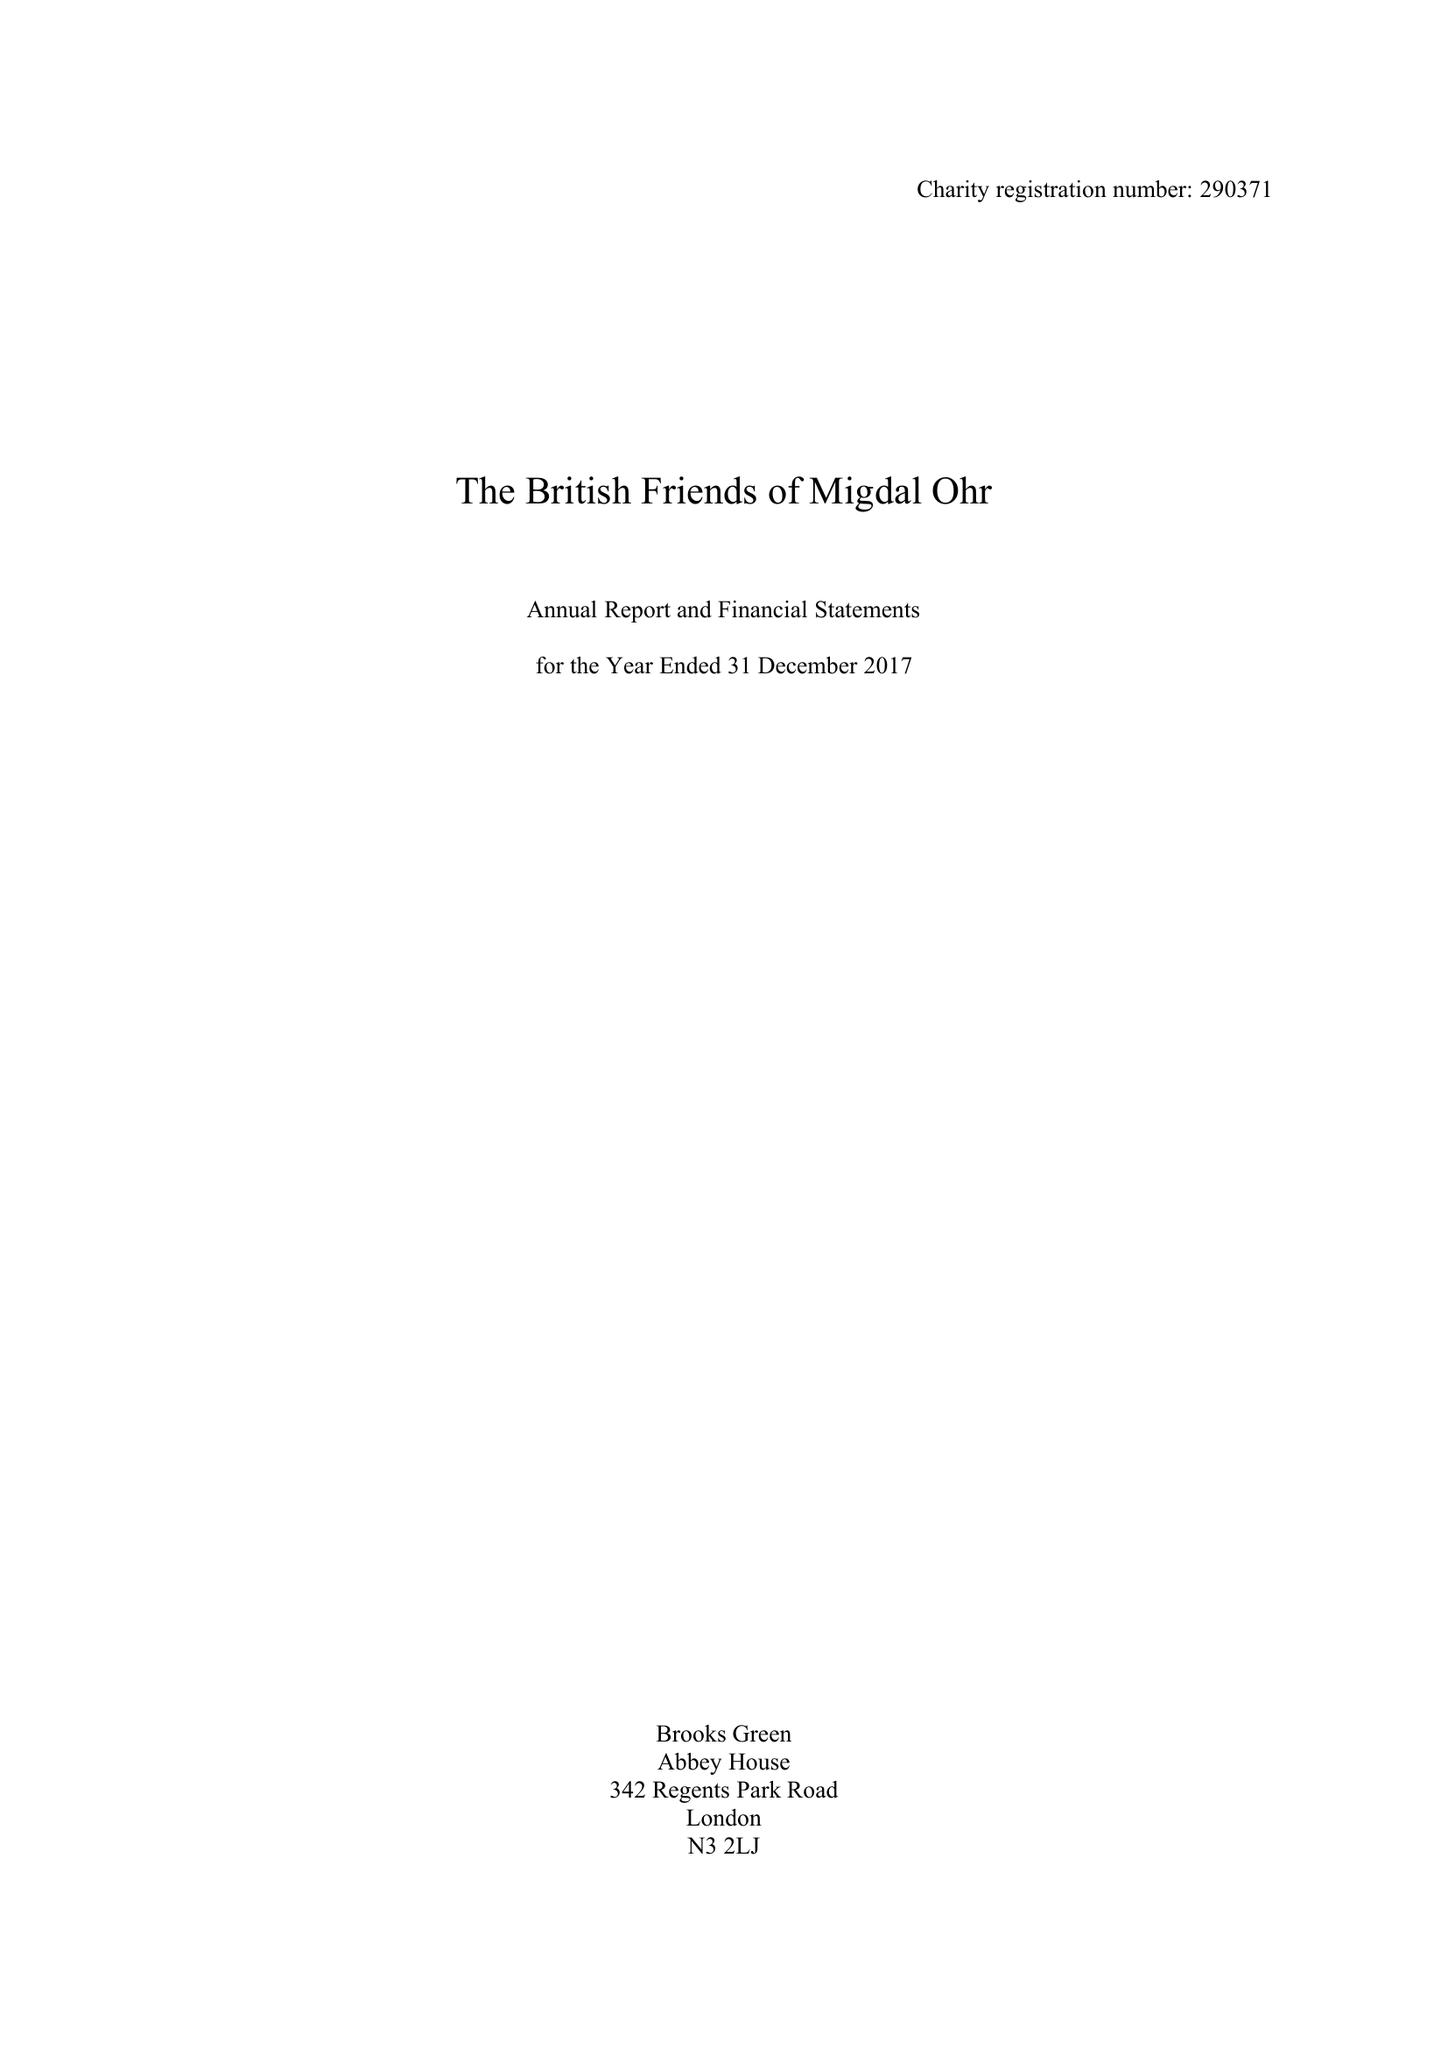What is the value for the report_date?
Answer the question using a single word or phrase. 2017-12-31 